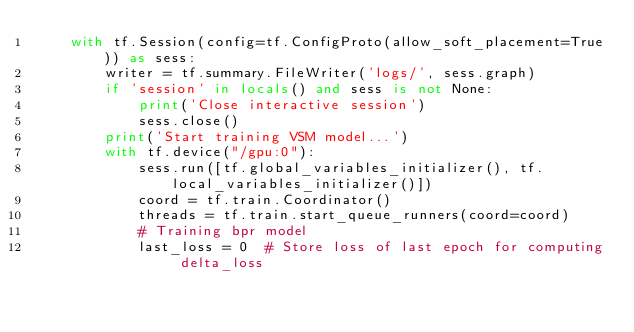Convert code to text. <code><loc_0><loc_0><loc_500><loc_500><_Python_>    with tf.Session(config=tf.ConfigProto(allow_soft_placement=True)) as sess:
        writer = tf.summary.FileWriter('logs/', sess.graph)
        if 'session' in locals() and sess is not None:
            print('Close interactive session')
            sess.close()
        print('Start training VSM model...')
        with tf.device("/gpu:0"):
            sess.run([tf.global_variables_initializer(), tf.local_variables_initializer()])
            coord = tf.train.Coordinator()
            threads = tf.train.start_queue_runners(coord=coord)
            # Training bpr model
            last_loss = 0  # Store loss of last epoch for computing delta_loss</code> 